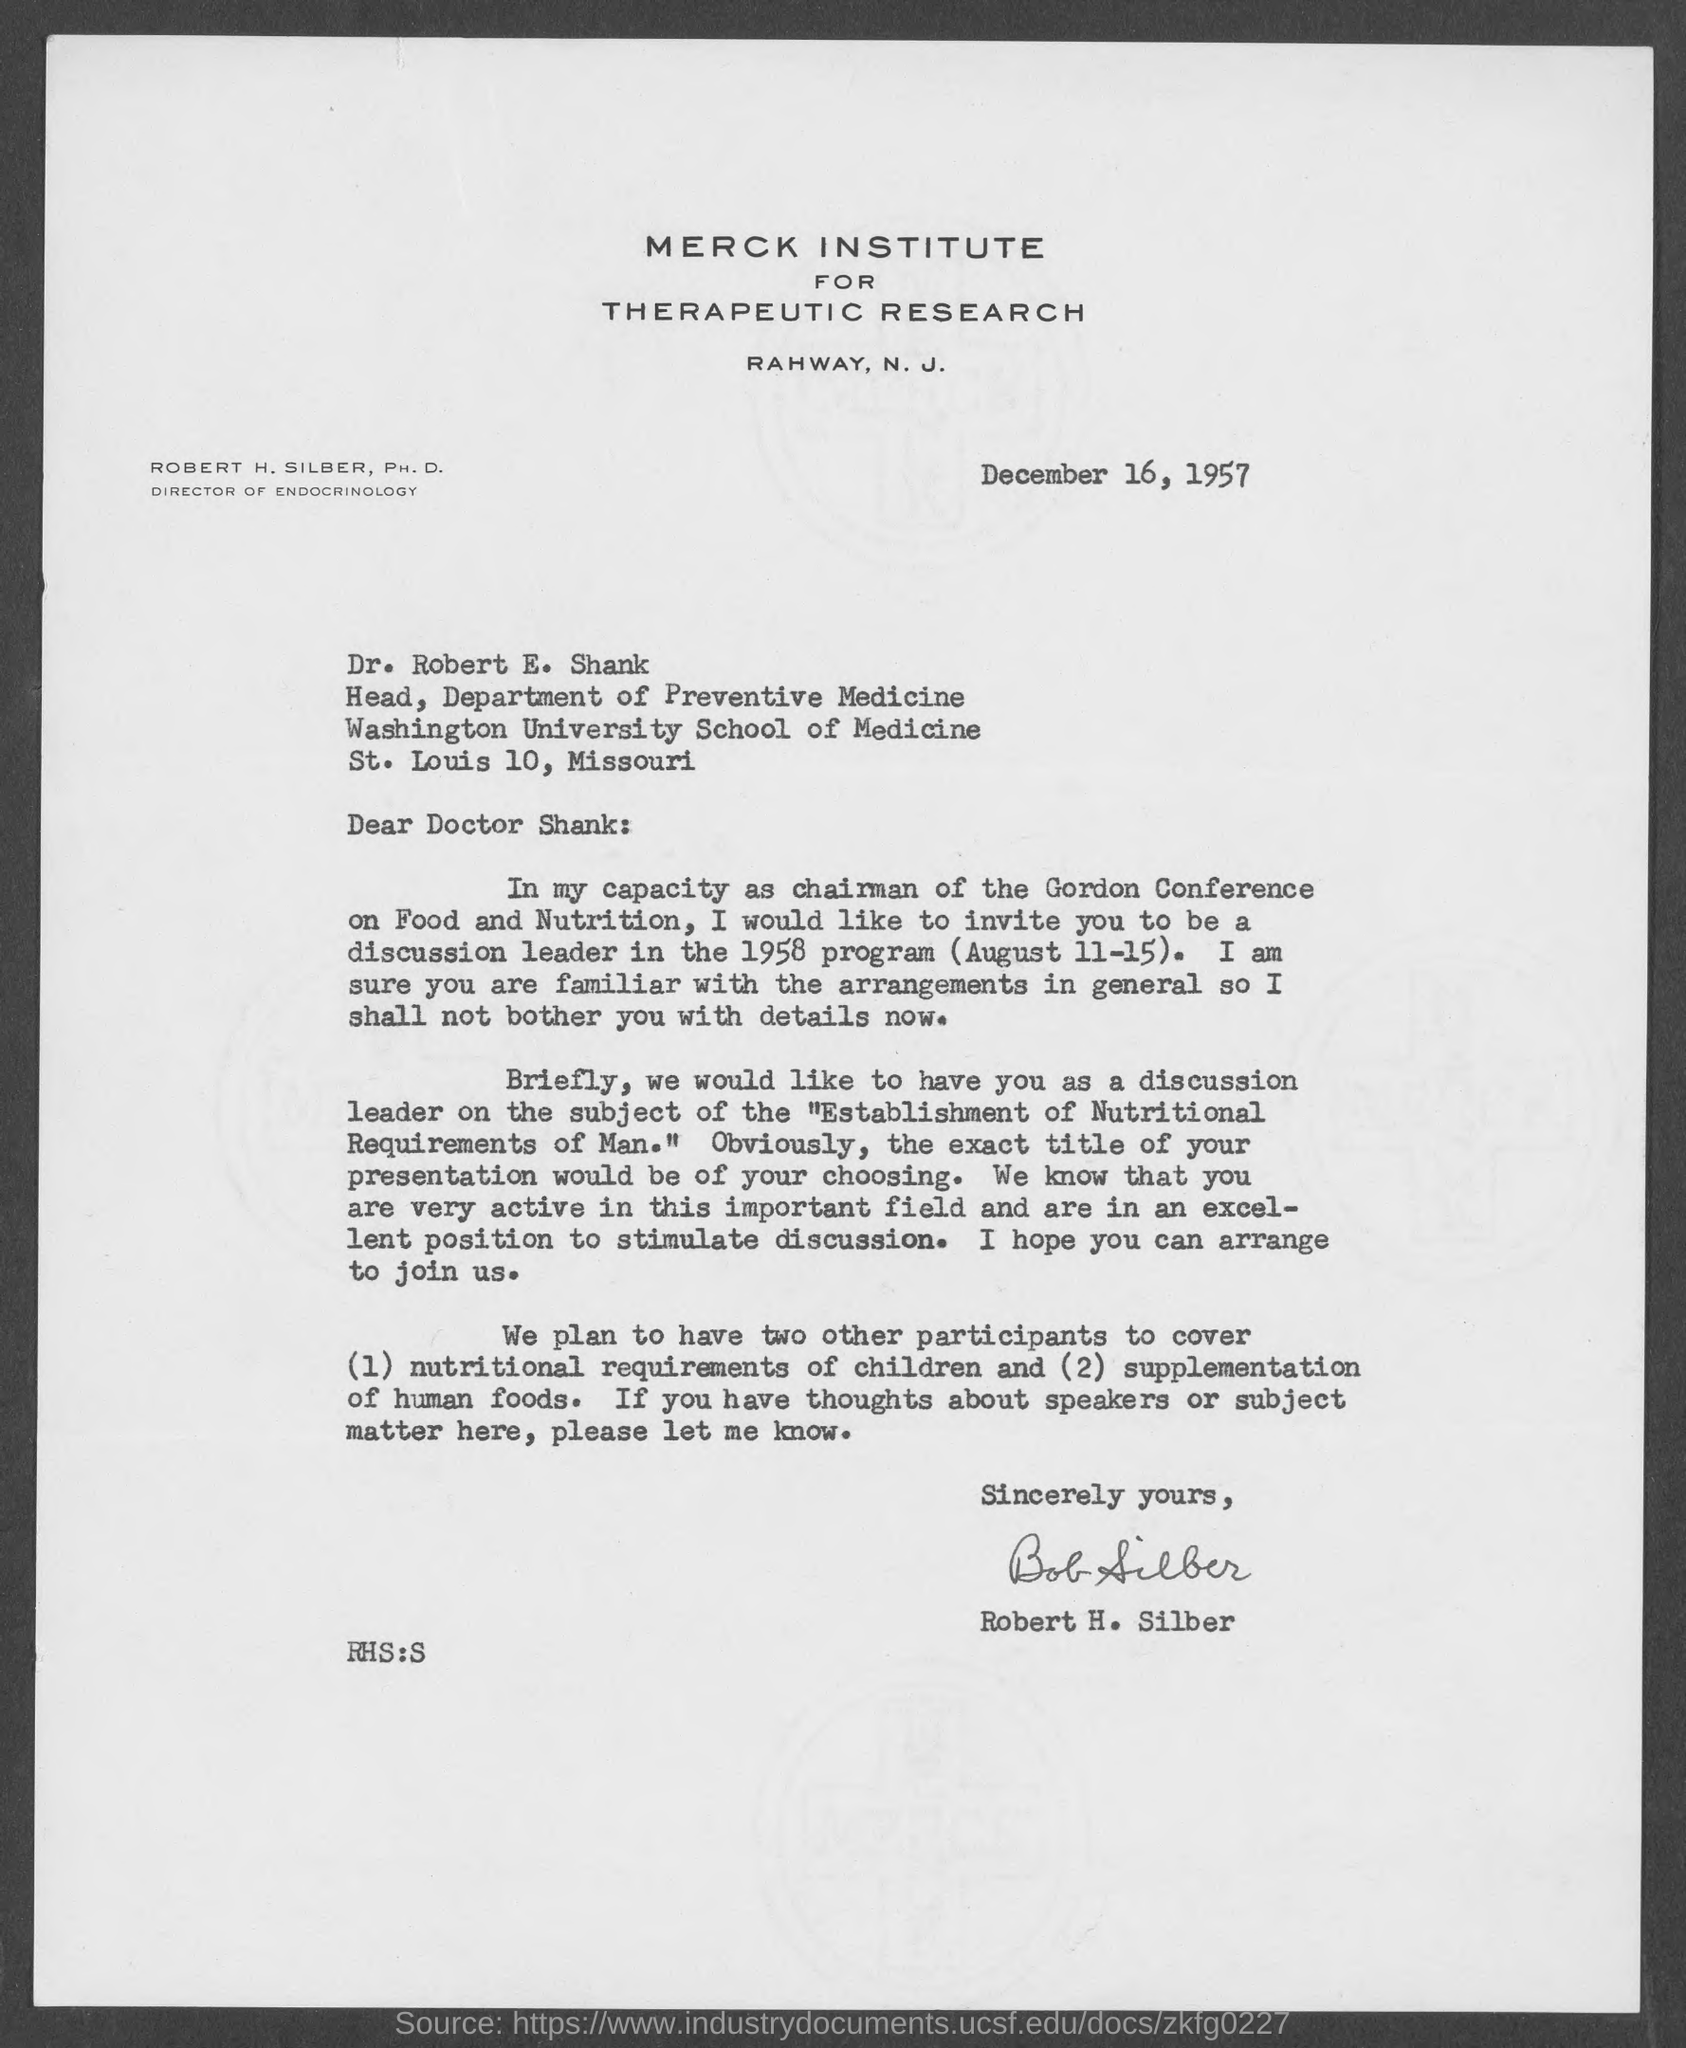Give some essential details in this illustration. The person who signed this letter is Robert H. Silber. The letterhead mentions "MERCK INSTITUTE FOR THERAPEUTIC RESEARCH. The issued date of this letter is December 16, 1957. 